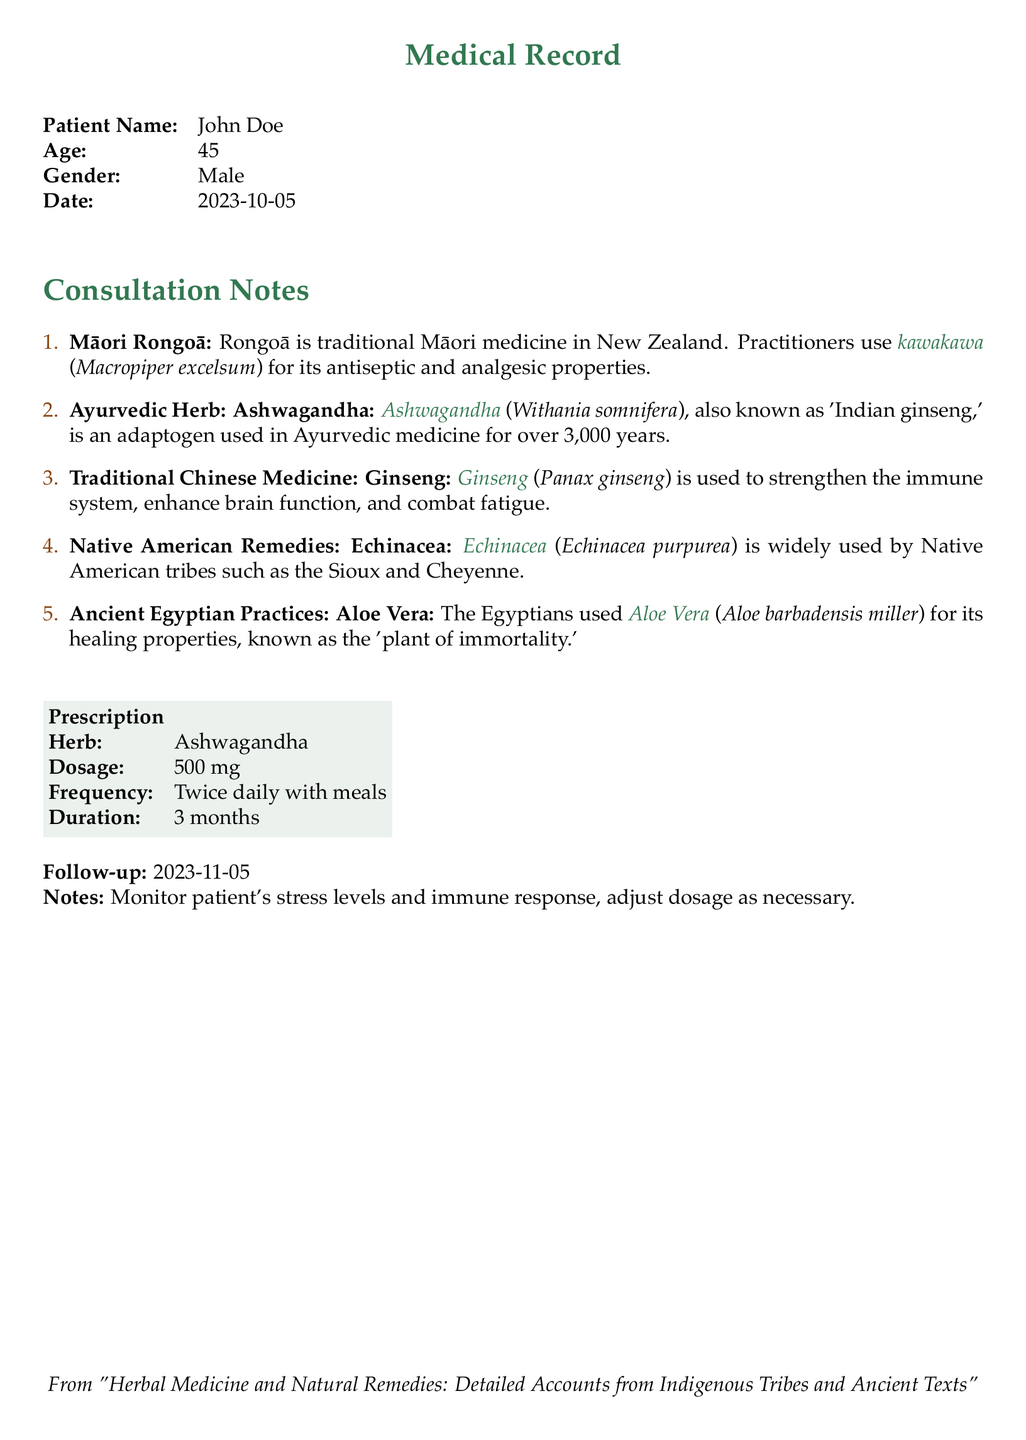what is the patient's name? The patient's name is clearly indicated in the medical record section, which is John Doe.
Answer: John Doe what is the age of the patient? The age of the patient is provided in the record as 45.
Answer: 45 what herb is prescribed in the document? The document specifies the prescribed herb as Ashwagandha.
Answer: Ashwagandha how often should the prescribed herb be taken? The document states that the herb should be taken twice daily with meals.
Answer: Twice daily when is the patient’s follow-up appointment scheduled? The follow-up date is mentioned in the notes section as 2023-11-05.
Answer: 2023-11-05 which indigenous tribes used Echinacea? The document lists the Sioux and Cheyenne as Native American tribes that use Echinacea.
Answer: Sioux and Cheyenne what is the dosage of Ashwagandha? The specified dosage of Ashwagandha in the prescription section is 500 mg.
Answer: 500 mg what are the healing properties of Aloe Vera according to ancient Egyptians? The document refers to Aloe Vera as known for its healing properties and the 'plant of immortality.'
Answer: plant of immortality what is the primary use of Ginseng in traditional Chinese medicine? The document states Ginseng is used to strengthen the immune system, enhance brain function, and combat fatigue.
Answer: strengthen the immune system, enhance brain function, and combat fatigue 